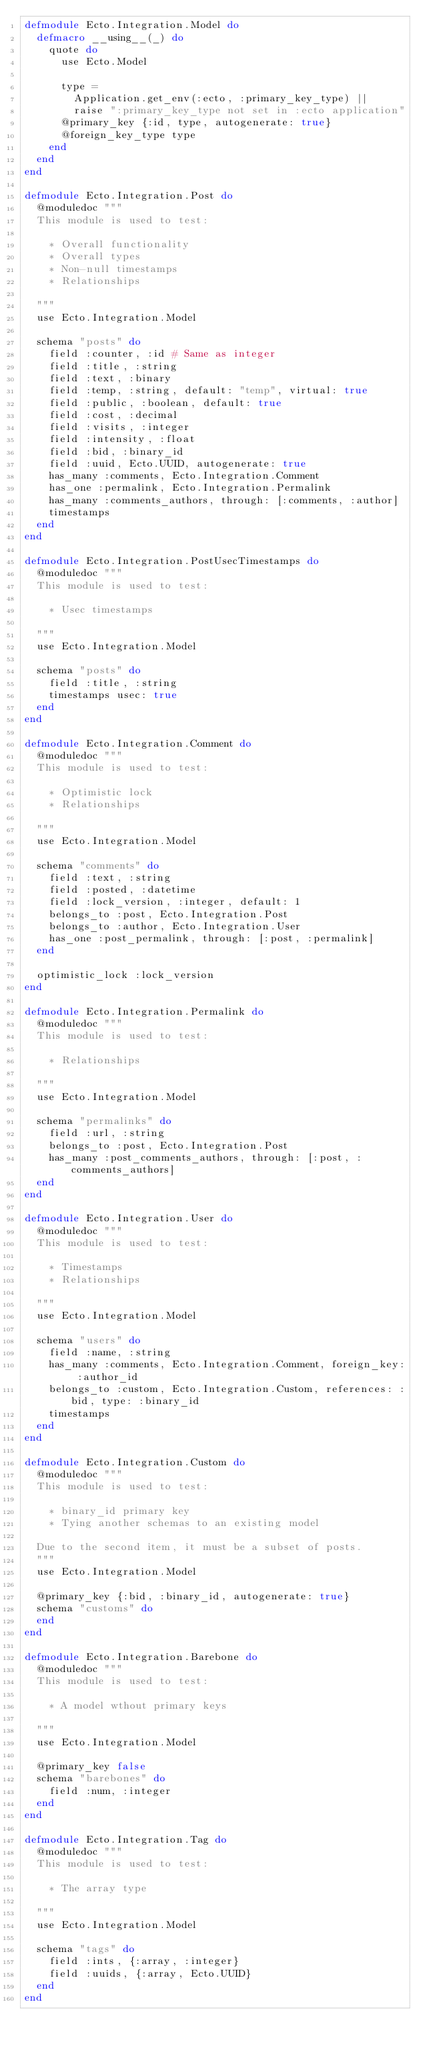Convert code to text. <code><loc_0><loc_0><loc_500><loc_500><_Elixir_>defmodule Ecto.Integration.Model do
  defmacro __using__(_) do
    quote do
      use Ecto.Model

      type =
        Application.get_env(:ecto, :primary_key_type) ||
        raise ":primary_key_type not set in :ecto application"
      @primary_key {:id, type, autogenerate: true}
      @foreign_key_type type
    end
  end
end

defmodule Ecto.Integration.Post do
  @moduledoc """
  This module is used to test:

    * Overall functionality
    * Overall types
    * Non-null timestamps
    * Relationships

  """
  use Ecto.Integration.Model

  schema "posts" do
    field :counter, :id # Same as integer
    field :title, :string
    field :text, :binary
    field :temp, :string, default: "temp", virtual: true
    field :public, :boolean, default: true
    field :cost, :decimal
    field :visits, :integer
    field :intensity, :float
    field :bid, :binary_id
    field :uuid, Ecto.UUID, autogenerate: true
    has_many :comments, Ecto.Integration.Comment
    has_one :permalink, Ecto.Integration.Permalink
    has_many :comments_authors, through: [:comments, :author]
    timestamps
  end
end

defmodule Ecto.Integration.PostUsecTimestamps do
  @moduledoc """
  This module is used to test:

    * Usec timestamps

  """
  use Ecto.Integration.Model

  schema "posts" do
    field :title, :string
    timestamps usec: true
  end
end

defmodule Ecto.Integration.Comment do
  @moduledoc """
  This module is used to test:

    * Optimistic lock
    * Relationships

  """
  use Ecto.Integration.Model

  schema "comments" do
    field :text, :string
    field :posted, :datetime
    field :lock_version, :integer, default: 1
    belongs_to :post, Ecto.Integration.Post
    belongs_to :author, Ecto.Integration.User
    has_one :post_permalink, through: [:post, :permalink]
  end

  optimistic_lock :lock_version
end

defmodule Ecto.Integration.Permalink do
  @moduledoc """
  This module is used to test:

    * Relationships

  """
  use Ecto.Integration.Model

  schema "permalinks" do
    field :url, :string
    belongs_to :post, Ecto.Integration.Post
    has_many :post_comments_authors, through: [:post, :comments_authors]
  end
end

defmodule Ecto.Integration.User do
  @moduledoc """
  This module is used to test:

    * Timestamps
    * Relationships

  """
  use Ecto.Integration.Model

  schema "users" do
    field :name, :string
    has_many :comments, Ecto.Integration.Comment, foreign_key: :author_id
    belongs_to :custom, Ecto.Integration.Custom, references: :bid, type: :binary_id
    timestamps
  end
end

defmodule Ecto.Integration.Custom do
  @moduledoc """
  This module is used to test:

    * binary_id primary key
    * Tying another schemas to an existing model

  Due to the second item, it must be a subset of posts.
  """
  use Ecto.Integration.Model

  @primary_key {:bid, :binary_id, autogenerate: true}
  schema "customs" do
  end
end

defmodule Ecto.Integration.Barebone do
  @moduledoc """
  This module is used to test:

    * A model wthout primary keys

  """
  use Ecto.Integration.Model

  @primary_key false
  schema "barebones" do
    field :num, :integer
  end
end

defmodule Ecto.Integration.Tag do
  @moduledoc """
  This module is used to test:

    * The array type

  """
  use Ecto.Integration.Model

  schema "tags" do
    field :ints, {:array, :integer}
    field :uuids, {:array, Ecto.UUID}
  end
end
</code> 